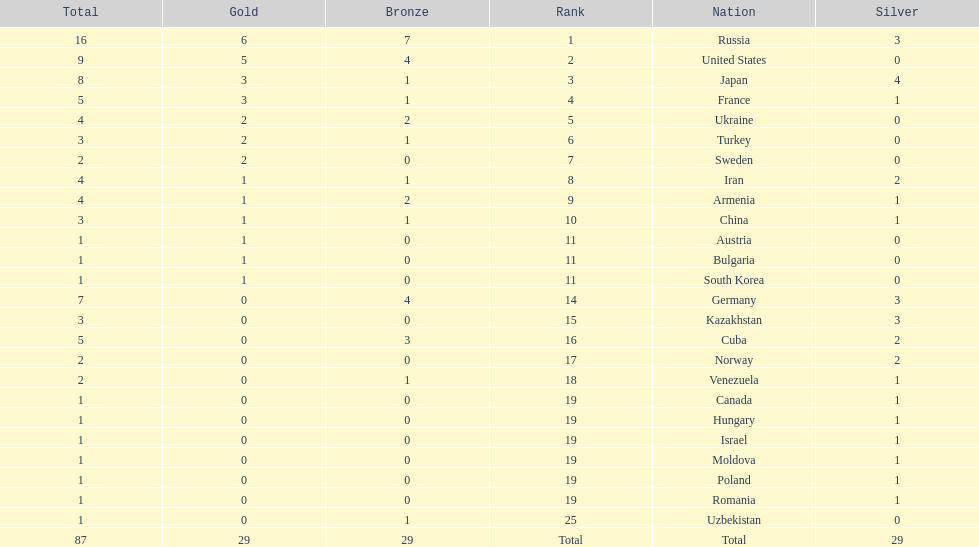Which nation was not in the top 10 iran or germany? Germany. 